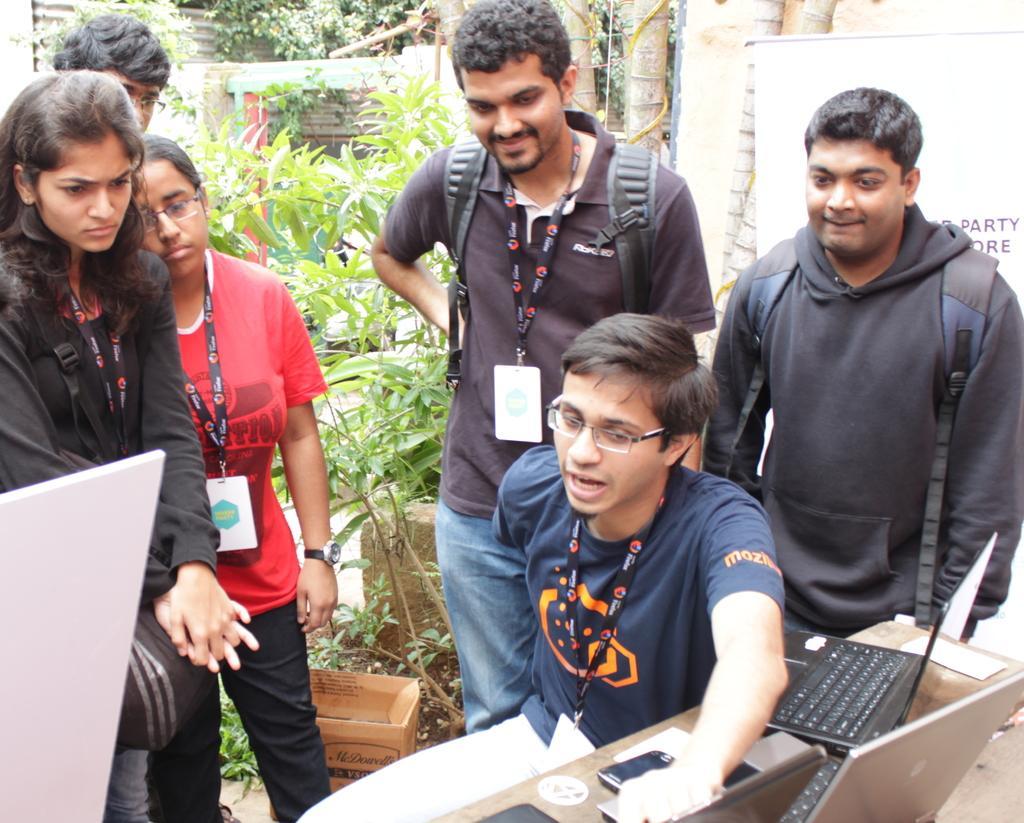In one or two sentences, can you explain what this image depicts? In front of the picture, we see a man in blue T-shirt is sitting on the chair. He is trying to explain something. In front of him, we see a table on which laptops and a mobile phone are placed. Behind him, we see five people are standing and all of them are listening to him. Behind them, we see a carton box, plants and trees. On the right side, we see a white board or a banner with some text written on it. In the left bottom, we see a white color board. There are trees and a building in the background. 